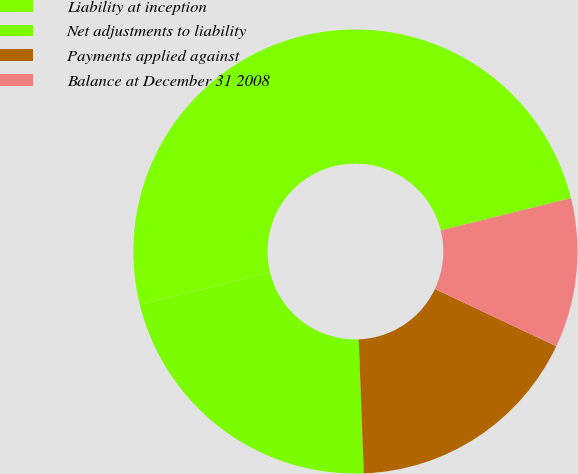<chart> <loc_0><loc_0><loc_500><loc_500><pie_chart><fcel>Liability at inception<fcel>Net adjustments to liability<fcel>Payments applied against<fcel>Balance at December 31 2008<nl><fcel>50.0%<fcel>21.74%<fcel>17.39%<fcel>10.87%<nl></chart> 